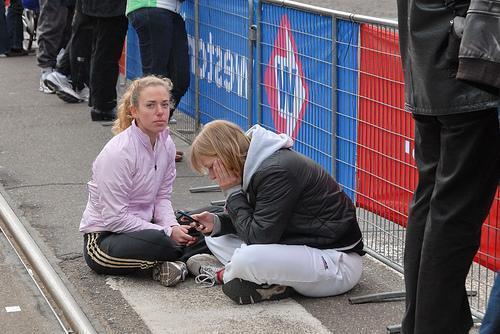How many people are sitting down?
Give a very brief answer. 2. How many people can you see?
Give a very brief answer. 7. 